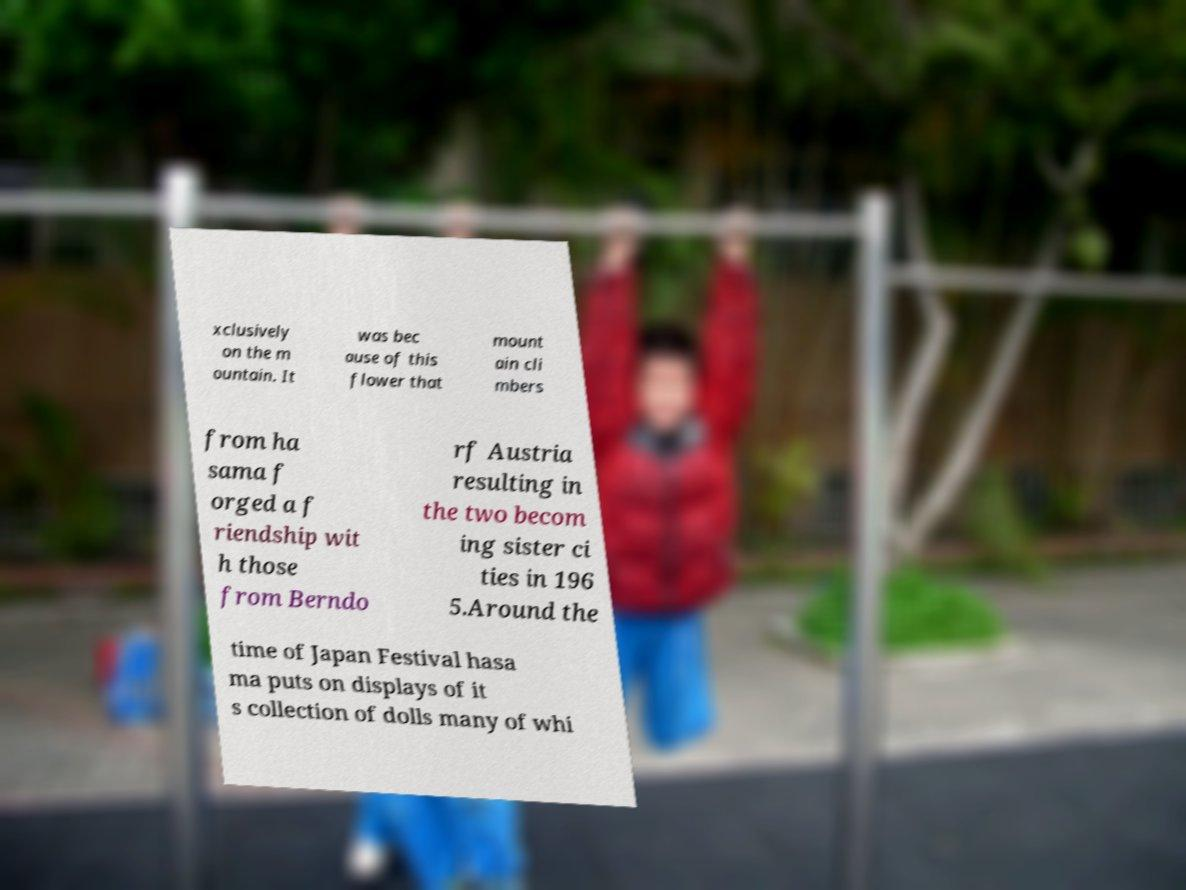Can you accurately transcribe the text from the provided image for me? xclusively on the m ountain. It was bec ause of this flower that mount ain cli mbers from ha sama f orged a f riendship wit h those from Berndo rf Austria resulting in the two becom ing sister ci ties in 196 5.Around the time of Japan Festival hasa ma puts on displays of it s collection of dolls many of whi 